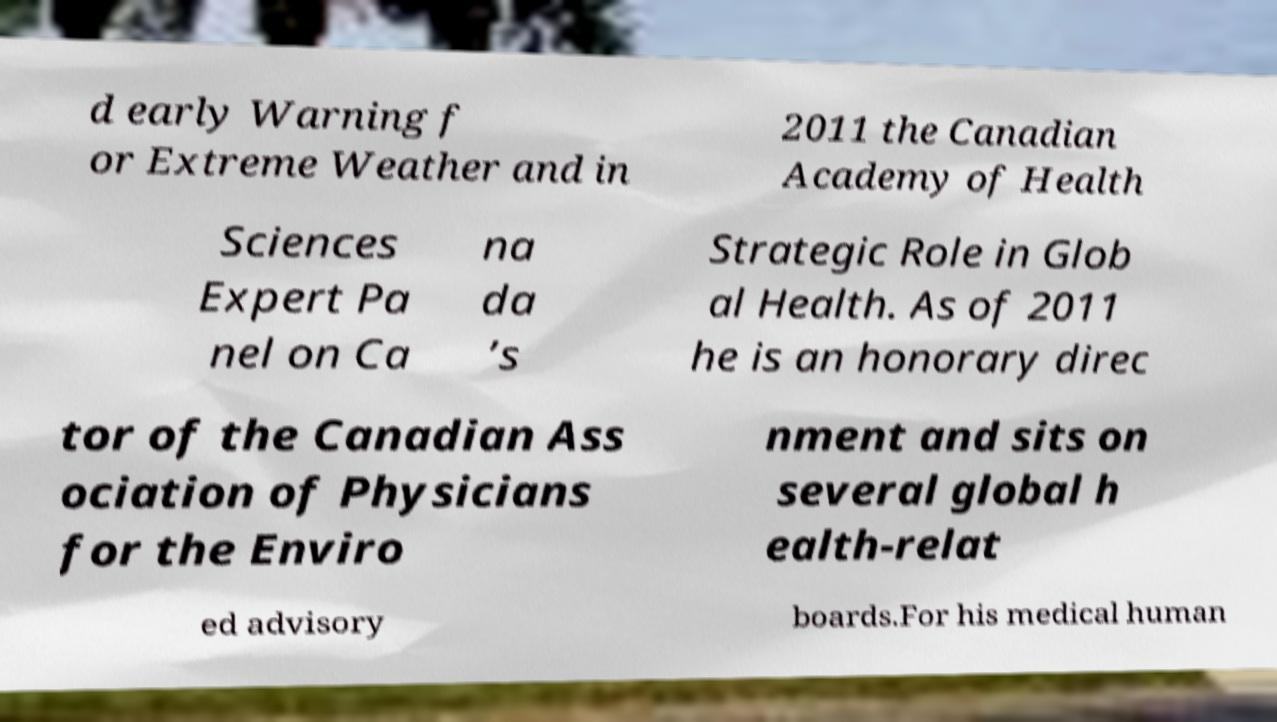There's text embedded in this image that I need extracted. Can you transcribe it verbatim? d early Warning f or Extreme Weather and in 2011 the Canadian Academy of Health Sciences Expert Pa nel on Ca na da ’s Strategic Role in Glob al Health. As of 2011 he is an honorary direc tor of the Canadian Ass ociation of Physicians for the Enviro nment and sits on several global h ealth-relat ed advisory boards.For his medical human 